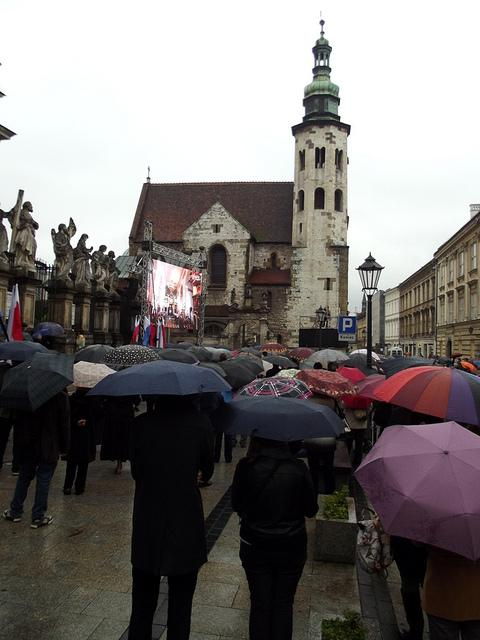Why are the people holding umbrellas?

Choices:
A) to buy
B) it's raining
C) to dance
D) it's snowing it's raining 